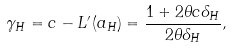Convert formula to latex. <formula><loc_0><loc_0><loc_500><loc_500>\gamma _ { H } = c - L ^ { \prime } ( a _ { H } ) = \frac { 1 + 2 \theta c \delta _ { H } } { 2 \theta \delta _ { H } } ,</formula> 